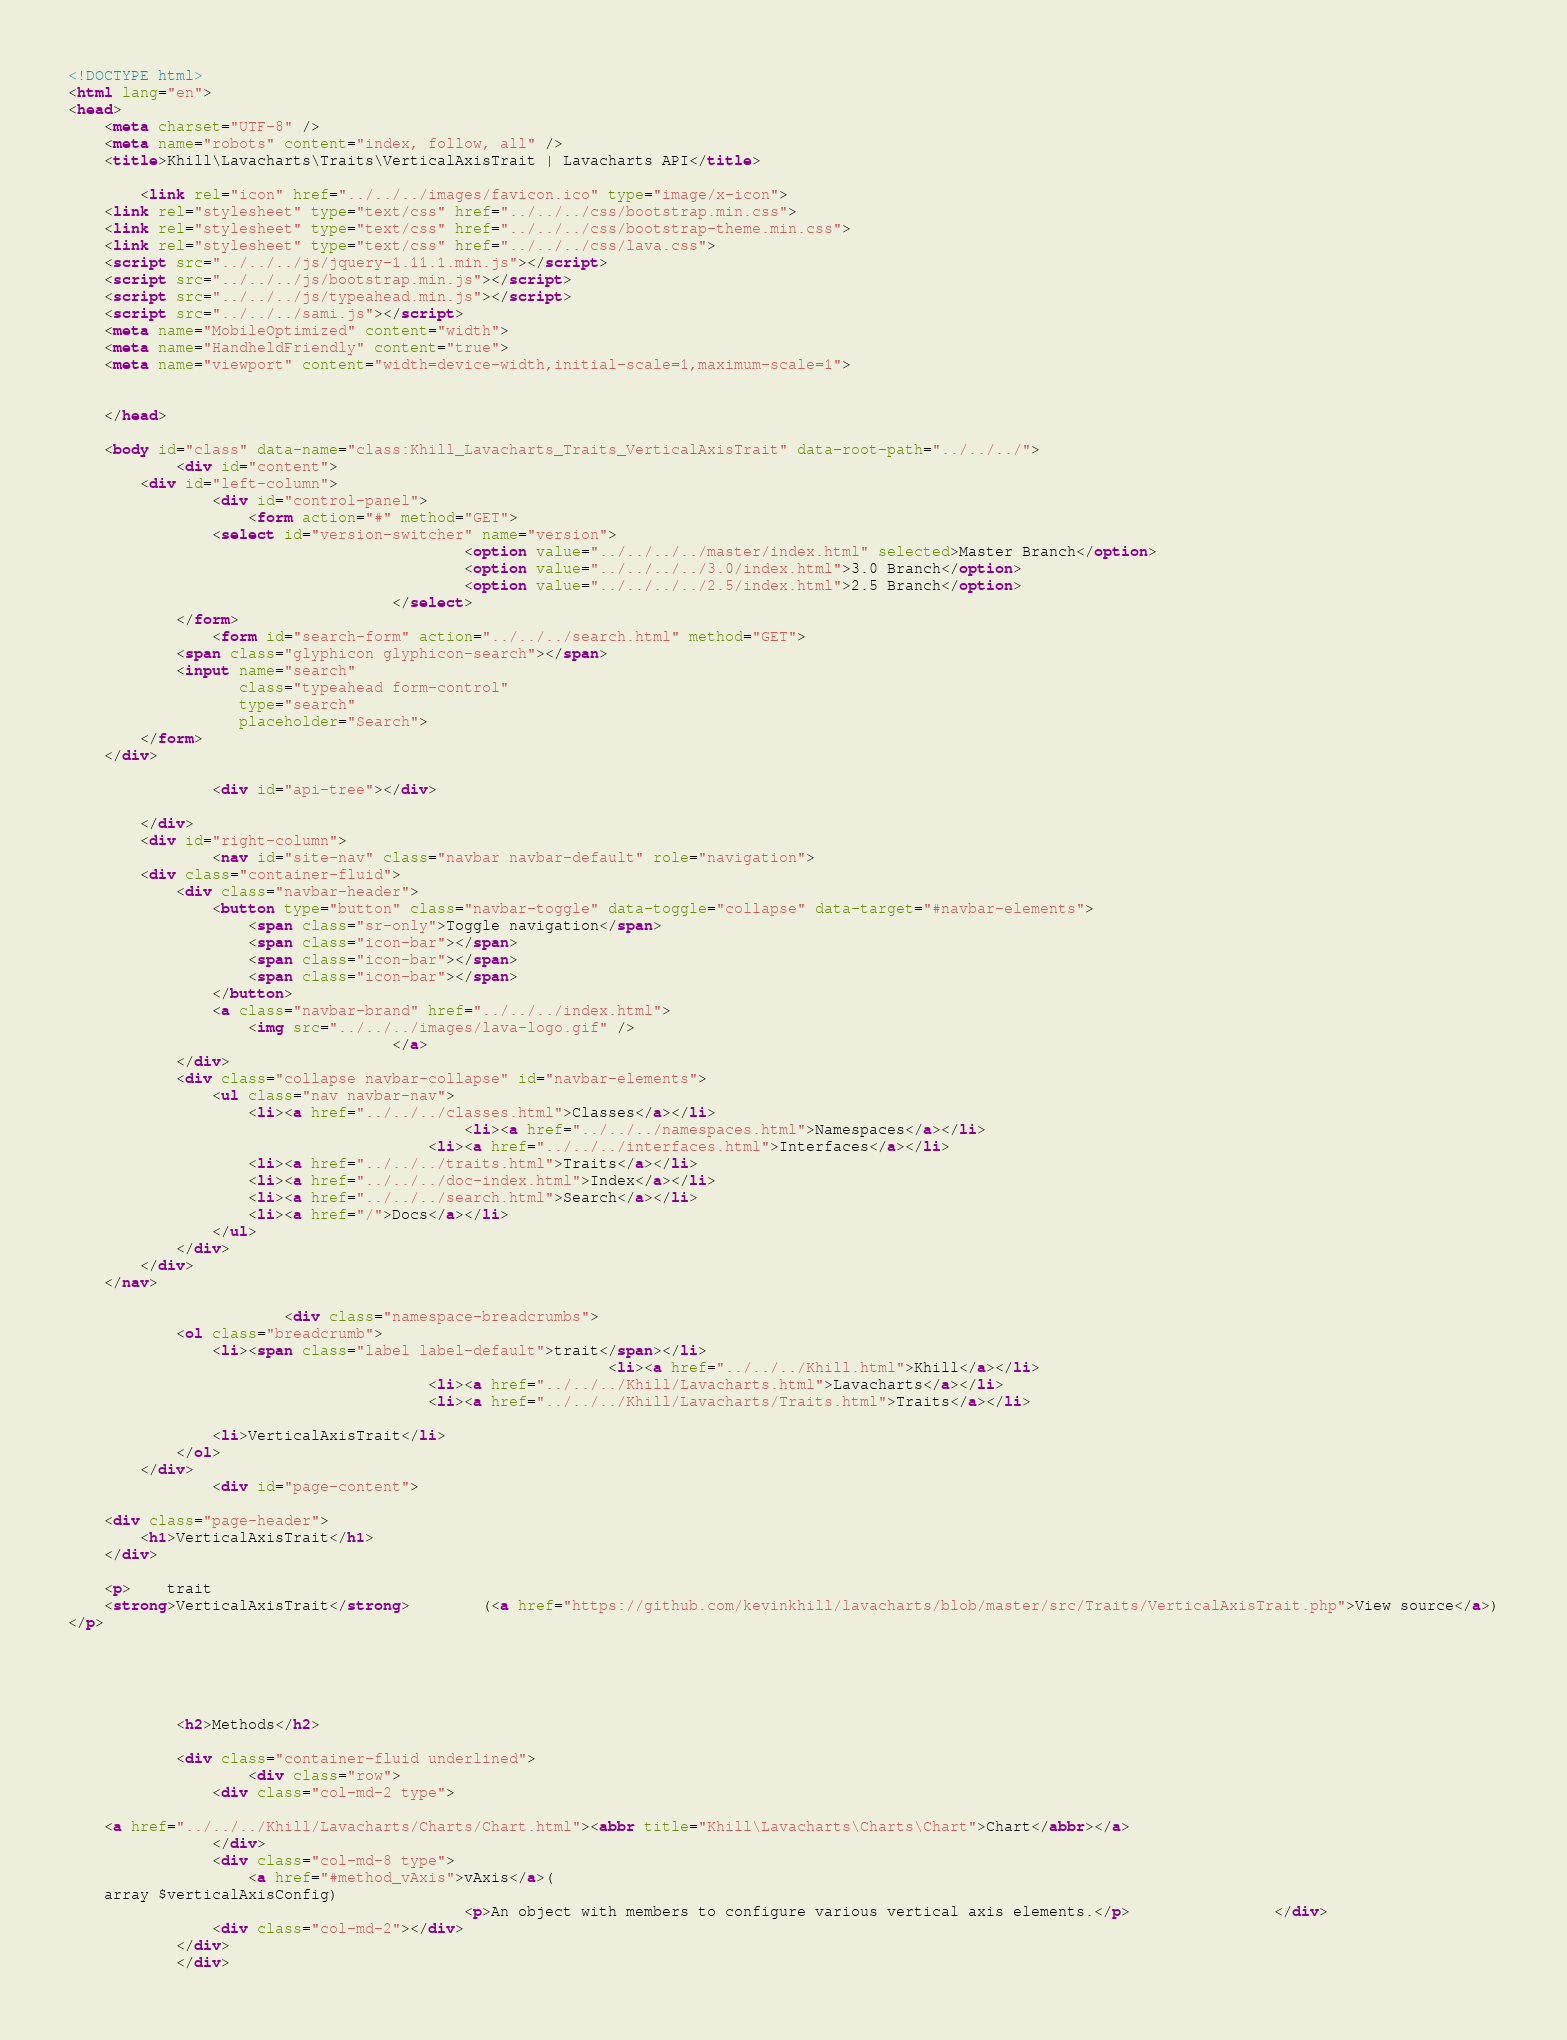Convert code to text. <code><loc_0><loc_0><loc_500><loc_500><_HTML_><!DOCTYPE html>
<html lang="en">
<head>
    <meta charset="UTF-8" />
    <meta name="robots" content="index, follow, all" />
    <title>Khill\Lavacharts\Traits\VerticalAxisTrait | Lavacharts API</title>

        <link rel="icon" href="../../../images/favicon.ico" type="image/x-icon">
    <link rel="stylesheet" type="text/css" href="../../../css/bootstrap.min.css">
    <link rel="stylesheet" type="text/css" href="../../../css/bootstrap-theme.min.css">
    <link rel="stylesheet" type="text/css" href="../../../css/lava.css">
    <script src="../../../js/jquery-1.11.1.min.js"></script>
    <script src="../../../js/bootstrap.min.js"></script>
    <script src="../../../js/typeahead.min.js"></script>
    <script src="../../../sami.js"></script>
    <meta name="MobileOptimized" content="width">
    <meta name="HandheldFriendly" content="true">
    <meta name="viewport" content="width=device-width,initial-scale=1,maximum-scale=1">

    
    </head>

    <body id="class" data-name="class:Khill_Lavacharts_Traits_VerticalAxisTrait" data-root-path="../../../">
            <div id="content">
        <div id="left-column">
                <div id="control-panel">
                    <form action="#" method="GET">
                <select id="version-switcher" name="version">
                                            <option value="../../../../master/index.html" selected>Master Branch</option>
                                            <option value="../../../../3.0/index.html">3.0 Branch</option>
                                            <option value="../../../../2.5/index.html">2.5 Branch</option>
                                    </select>
            </form>
                <form id="search-form" action="../../../search.html" method="GET">
            <span class="glyphicon glyphicon-search"></span>
            <input name="search"
                   class="typeahead form-control"
                   type="search"
                   placeholder="Search">
        </form>
    </div>

                <div id="api-tree"></div>

        </div>
        <div id="right-column">
                <nav id="site-nav" class="navbar navbar-default" role="navigation">
        <div class="container-fluid">
            <div class="navbar-header">
                <button type="button" class="navbar-toggle" data-toggle="collapse" data-target="#navbar-elements">
                    <span class="sr-only">Toggle navigation</span>
                    <span class="icon-bar"></span>
                    <span class="icon-bar"></span>
                    <span class="icon-bar"></span>
                </button>
                <a class="navbar-brand" href="../../../index.html">
                    <img src="../../../images/lava-logo.gif" />
                                    </a>
            </div>
            <div class="collapse navbar-collapse" id="navbar-elements">
                <ul class="nav navbar-nav">
                    <li><a href="../../../classes.html">Classes</a></li>
                                            <li><a href="../../../namespaces.html">Namespaces</a></li>
                                        <li><a href="../../../interfaces.html">Interfaces</a></li>
                    <li><a href="../../../traits.html">Traits</a></li>
                    <li><a href="../../../doc-index.html">Index</a></li>
                    <li><a href="../../../search.html">Search</a></li>
                    <li><a href="/">Docs</a></li>
                </ul>
            </div>
        </div>
    </nav>

                        <div class="namespace-breadcrumbs">
            <ol class="breadcrumb">
                <li><span class="label label-default">trait</span></li>
                                                            <li><a href="../../../Khill.html">Khill</a></li>
                                        <li><a href="../../../Khill/Lavacharts.html">Lavacharts</a></li>
                                        <li><a href="../../../Khill/Lavacharts/Traits.html">Traits</a></li>
    
                <li>VerticalAxisTrait</li>
            </ol>
        </div>
                <div id="page-content">
                
    <div class="page-header">
        <h1>VerticalAxisTrait</h1>
    </div>

    <p>    trait
    <strong>VerticalAxisTrait</strong>        (<a href="https://github.com/kevinkhill/lavacharts/blob/master/src/Traits/VerticalAxisTrait.php">View source</a>)
</p>

    
    
    
    
            <h2>Methods</h2>

            <div class="container-fluid underlined">
                    <div class="row">
                <div class="col-md-2 type">
                    
    <a href="../../../Khill/Lavacharts/Charts/Chart.html"><abbr title="Khill\Lavacharts\Charts\Chart">Chart</abbr></a>
                </div>
                <div class="col-md-8 type">
                    <a href="#method_vAxis">vAxis</a>(
    array $verticalAxisConfig)
                                            <p>An object with members to configure various vertical axis elements.</p>                </div>
                <div class="col-md-2"></div>
            </div>
            </div>

</code> 